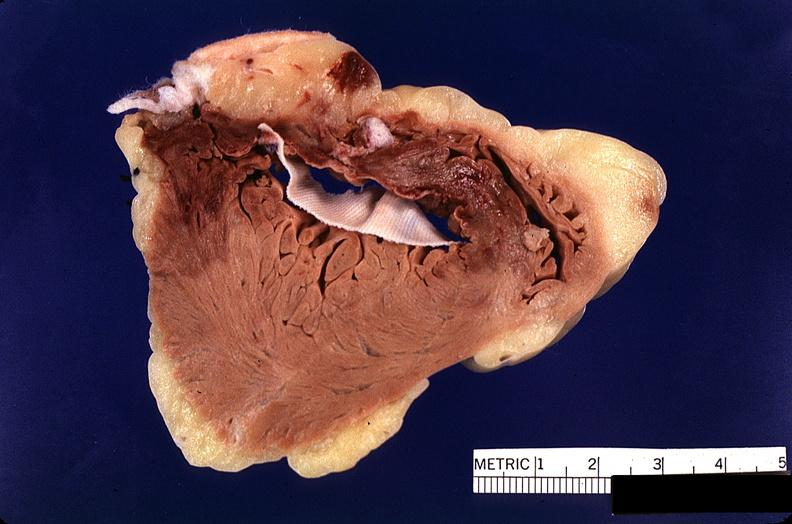does polycystic disease show heart, myocardial infarction, surgery to repair interventricular septum rupture?
Answer the question using a single word or phrase. No 